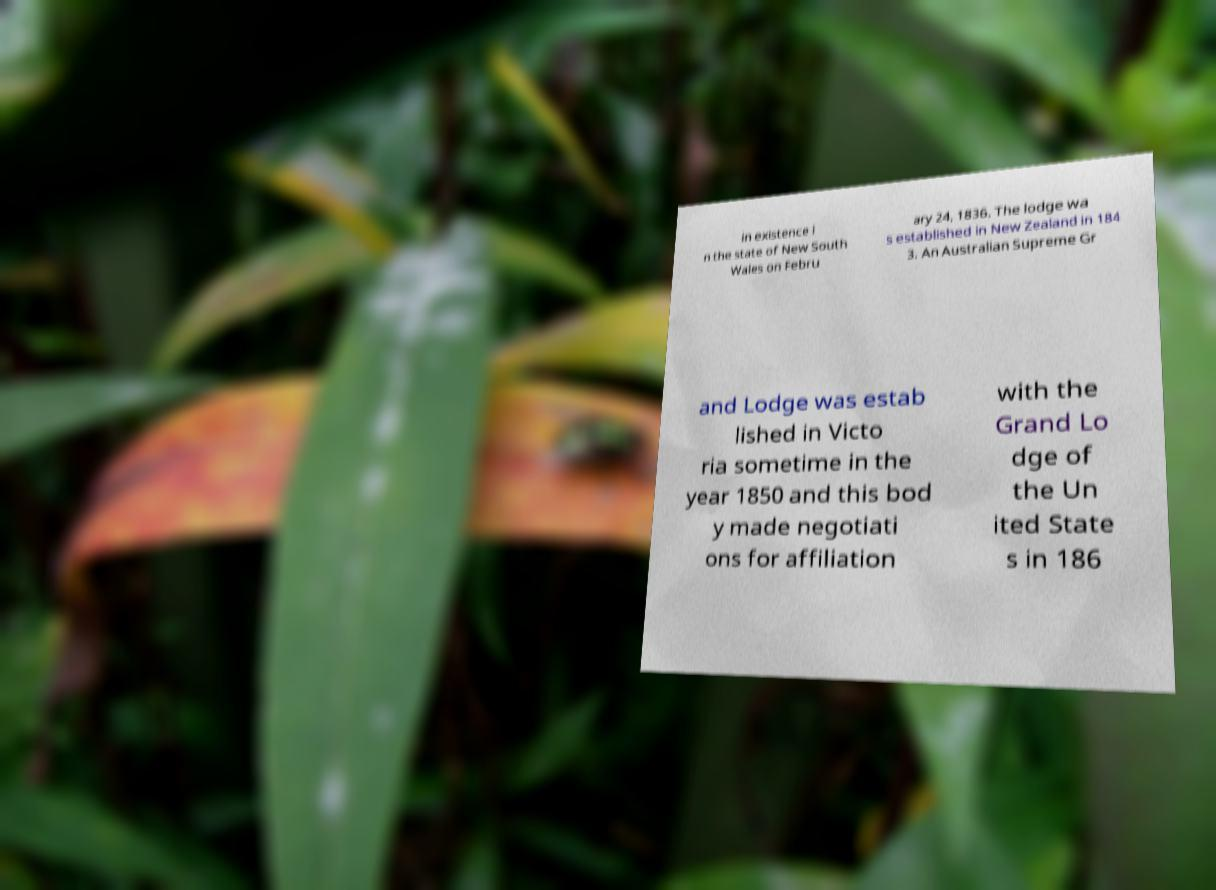Could you assist in decoding the text presented in this image and type it out clearly? in existence i n the state of New South Wales on Febru ary 24, 1836. The lodge wa s established in New Zealand in 184 3. An Australian Supreme Gr and Lodge was estab lished in Victo ria sometime in the year 1850 and this bod y made negotiati ons for affiliation with the Grand Lo dge of the Un ited State s in 186 